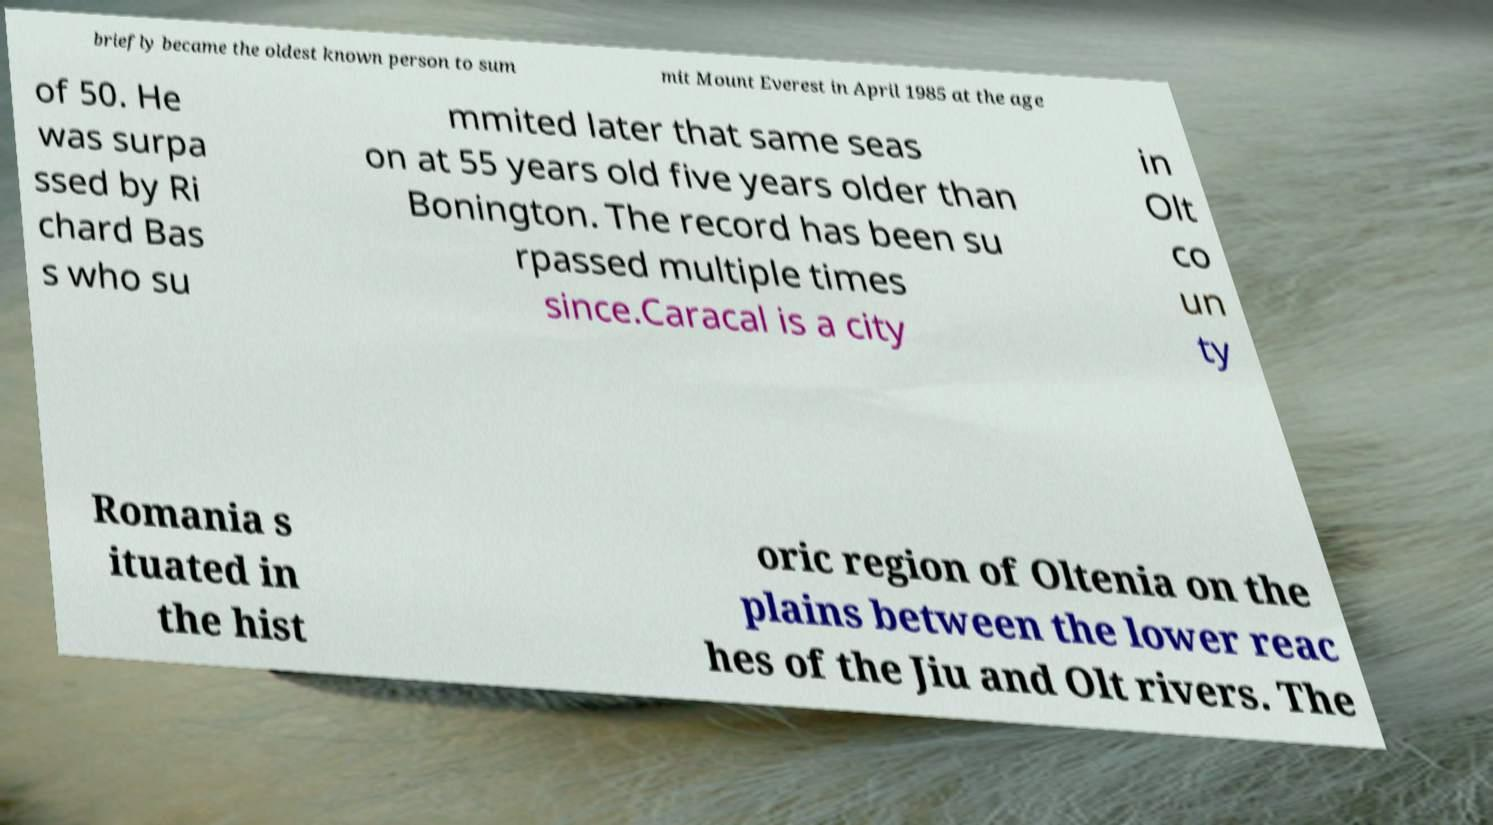Can you accurately transcribe the text from the provided image for me? briefly became the oldest known person to sum mit Mount Everest in April 1985 at the age of 50. He was surpa ssed by Ri chard Bas s who su mmited later that same seas on at 55 years old five years older than Bonington. The record has been su rpassed multiple times since.Caracal is a city in Olt co un ty Romania s ituated in the hist oric region of Oltenia on the plains between the lower reac hes of the Jiu and Olt rivers. The 